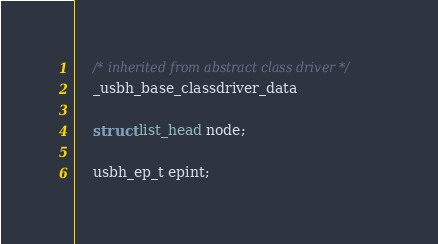Convert code to text. <code><loc_0><loc_0><loc_500><loc_500><_C_>	/* inherited from abstract class driver */
	_usbh_base_classdriver_data

	struct list_head node;

	usbh_ep_t epint;</code> 